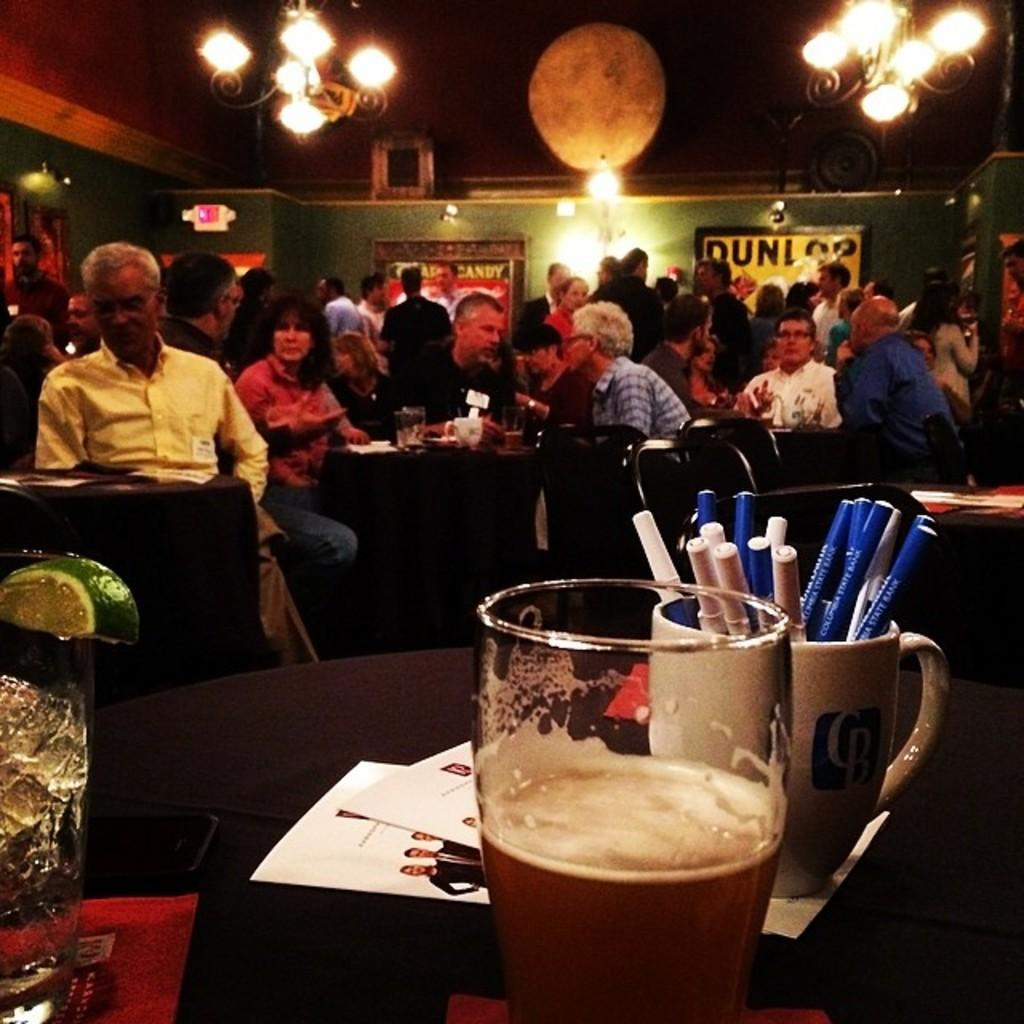<image>
Relay a brief, clear account of the picture shown. A poster hangs on a bar wall and starts with the letter D. 